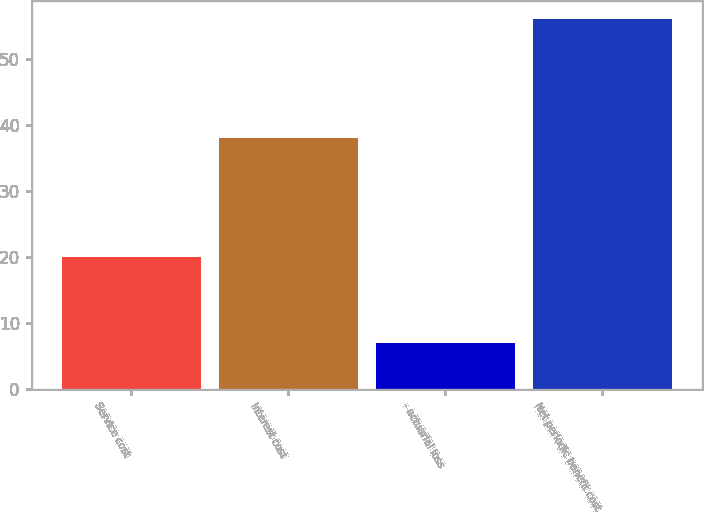<chart> <loc_0><loc_0><loc_500><loc_500><bar_chart><fcel>Service cost<fcel>Interest cost<fcel>- actuarial loss<fcel>Net periodic benefit cost<nl><fcel>20<fcel>38<fcel>7<fcel>56<nl></chart> 